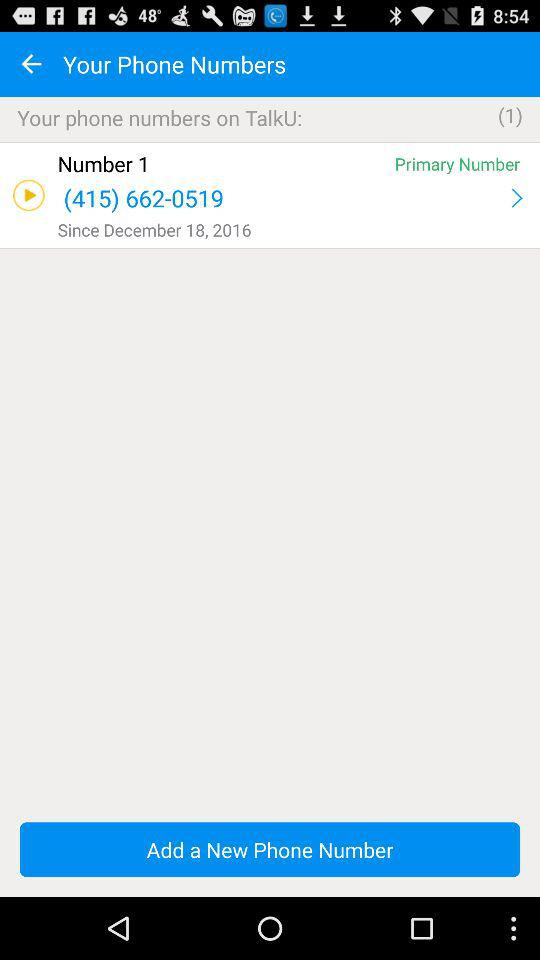How many new notifications are on TalkU?
When the provided information is insufficient, respond with <no answer>. <no answer> 